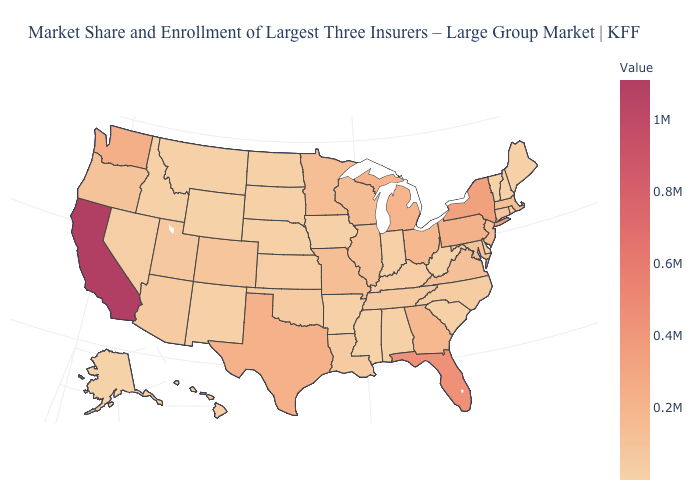Does the map have missing data?
Concise answer only. No. Does the map have missing data?
Write a very short answer. No. Does Idaho have the lowest value in the USA?
Write a very short answer. No. Among the states that border Tennessee , does Mississippi have the lowest value?
Quick response, please. Yes. Among the states that border Delaware , which have the highest value?
Keep it brief. Pennsylvania. 